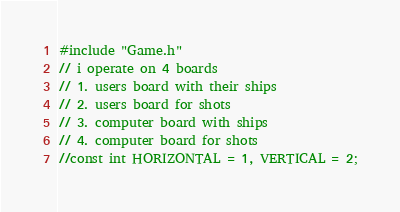Convert code to text. <code><loc_0><loc_0><loc_500><loc_500><_C++_>#include "Game.h"
// i operate on 4 boards
// 1. users board with their ships
// 2. users board for shots
// 3. computer board with ships
// 4. computer board for shots
//const int HORIZONTAL = 1, VERTICAL = 2;</code> 